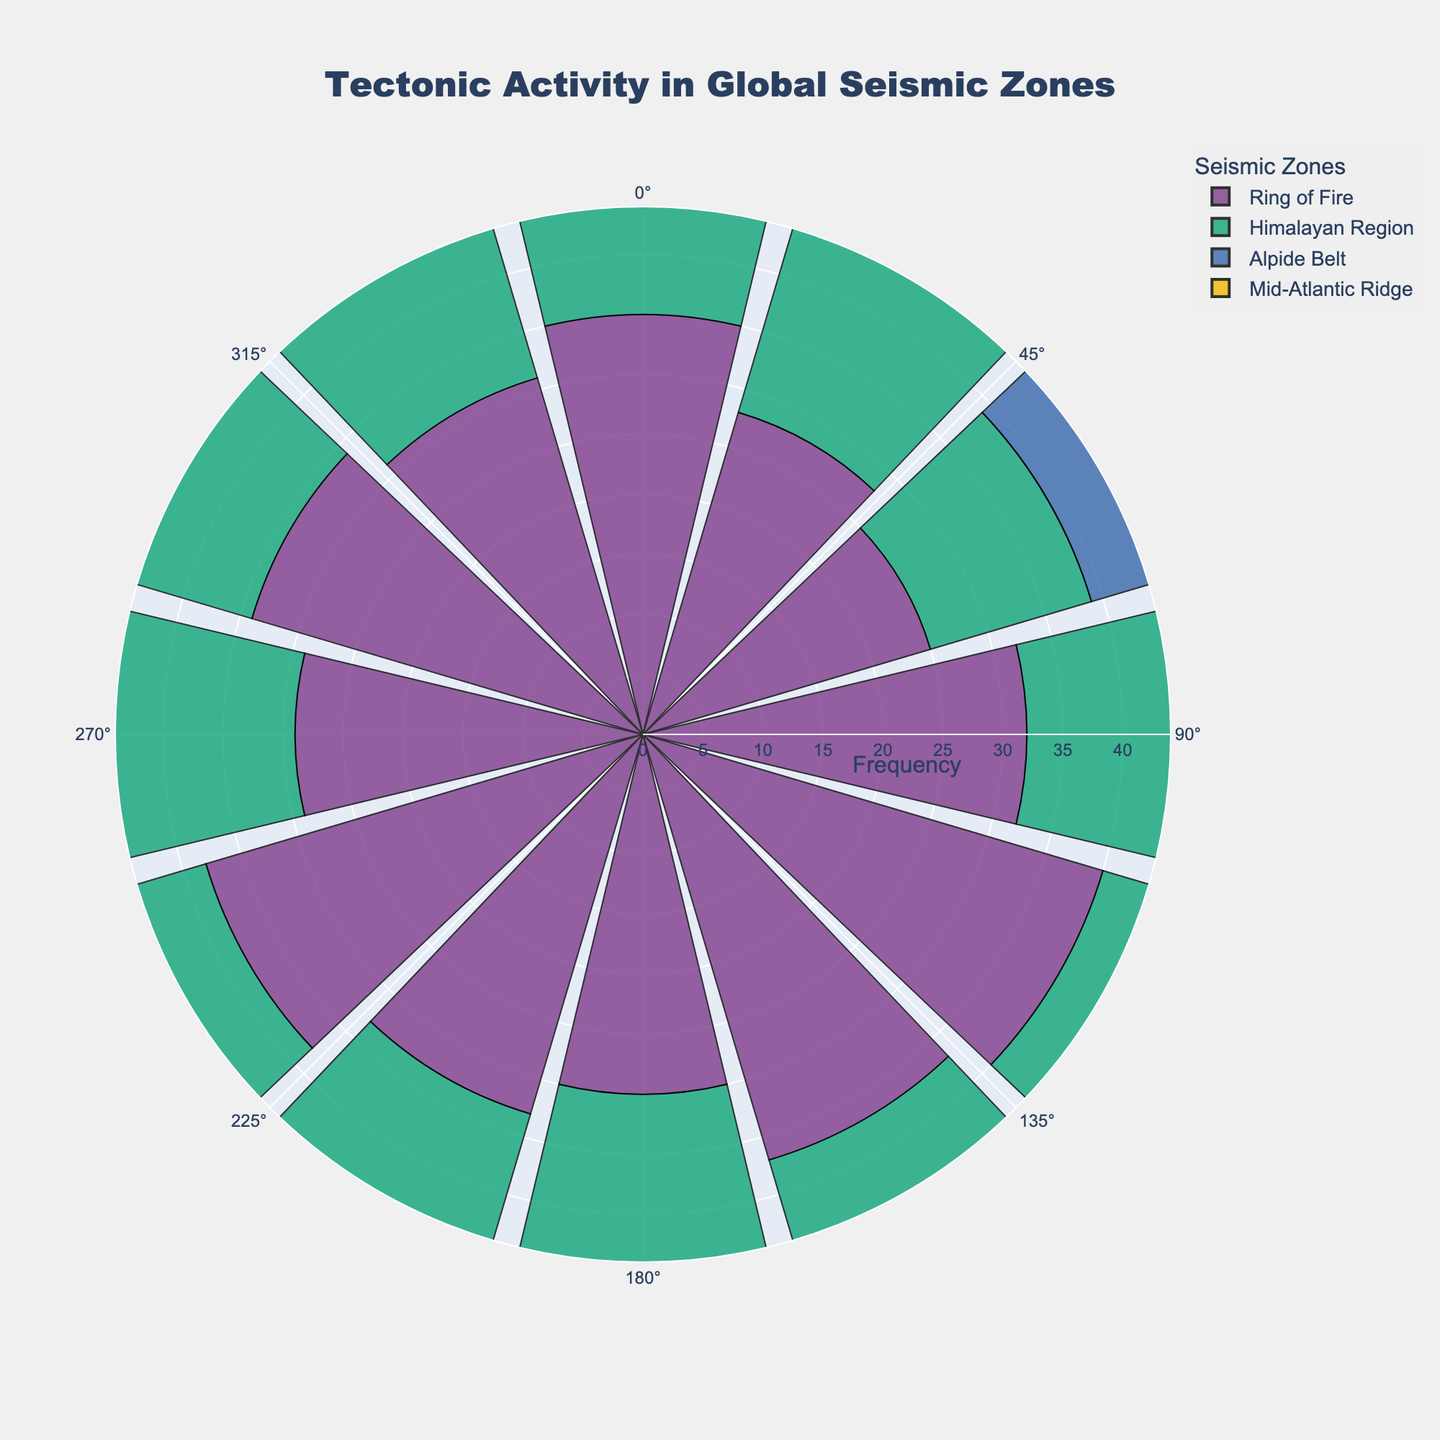What's the title of the figure? The title is typically displayed at the top of the chart. By looking there, we can see the text of the title.
Answer: "Tectonic Activity in Global Seismic Zones" How many seismic zones are represented in the figure? By counting the distinct labels in the legend or the different colored regions on the chart, we can identify the number of seismic zones.
Answer: 4 Which seismic zone has the highest frequency of tectonic activities? The "Ring of Fire" consistently shows higher frequencies when compared to other regions in different directions on the polar chart.
Answer: Ring of Fire What's the range of frequency values shown on the radial axis? By looking at the radial axis labels and the outermost circle, we can determine the range. The max frequency will be slightly higher than the highest value in the data.
Answer: 0 to around 44 How does the frequency of activities in the "Mid-Atlantic Ridge" at 60 degrees compare to the "Alpide Belt" at the same angle? By comparing the radial lengths of bars at 60 degrees for both regions, we can infer that the "Mid-Atlantic Ridge" has a lower frequency.
Answer: Mid-Atlantic Ridge: 7, Alpide Belt: 12 Which seismic zone has the highest recorded intensity value and at what angle? By inspecting the annotations or labels closest to the outer edge of the chart, we find the highest intensity noted.
Answer: Ring of Fire, 150 degrees, Intensity: 8.2 Which region shows the least variability in its frequency values across different directions? By observing the spread and uniformity of the bars for each region; the "Mid-Atlantic Ridge" bars are relatively consistent in length across different angles.
Answer: Mid-Atlantic Ridge 